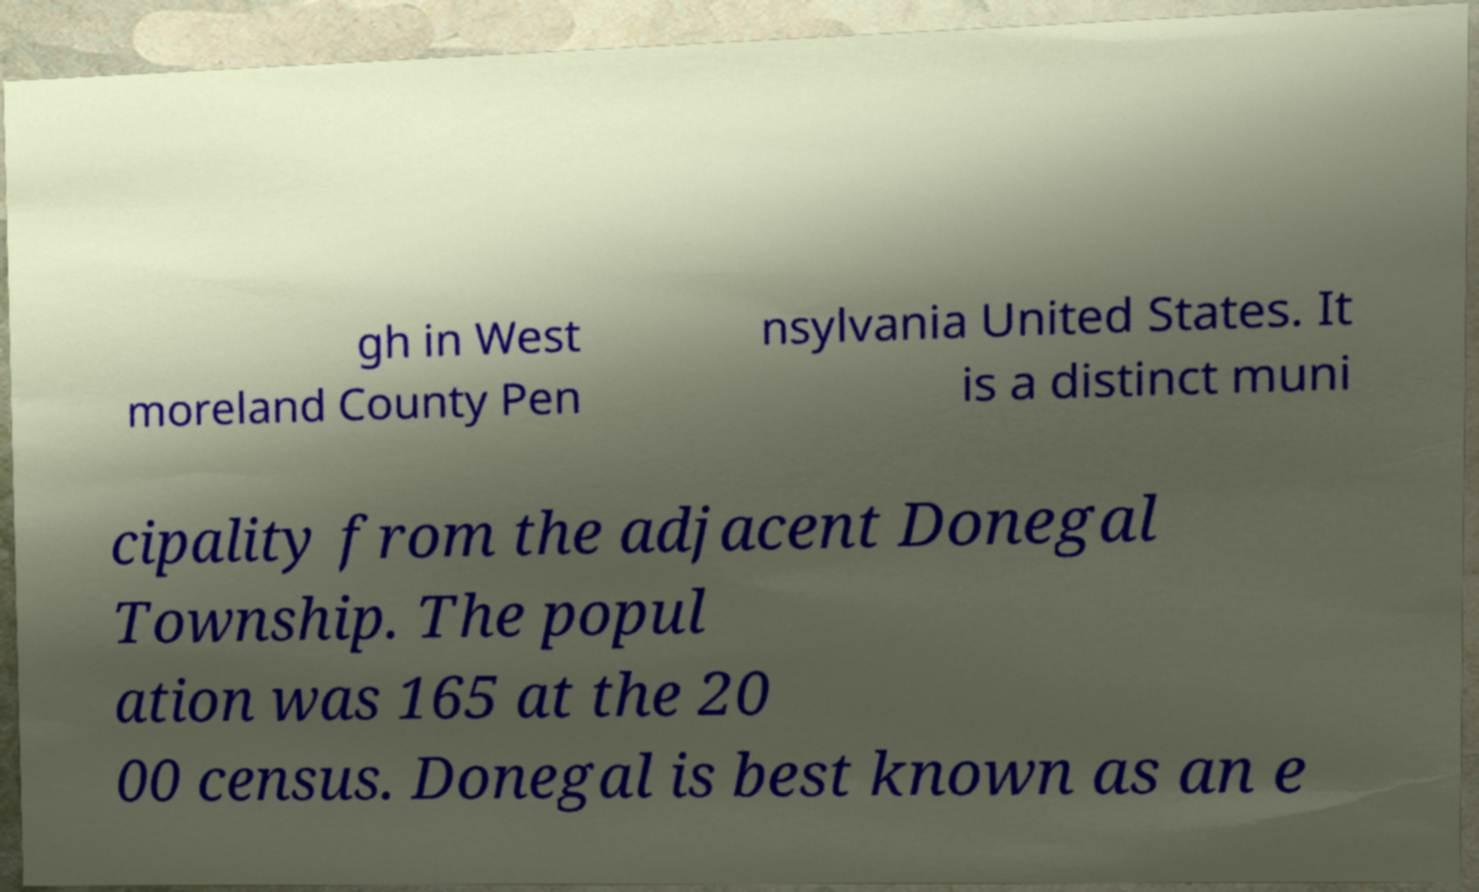What messages or text are displayed in this image? I need them in a readable, typed format. gh in West moreland County Pen nsylvania United States. It is a distinct muni cipality from the adjacent Donegal Township. The popul ation was 165 at the 20 00 census. Donegal is best known as an e 